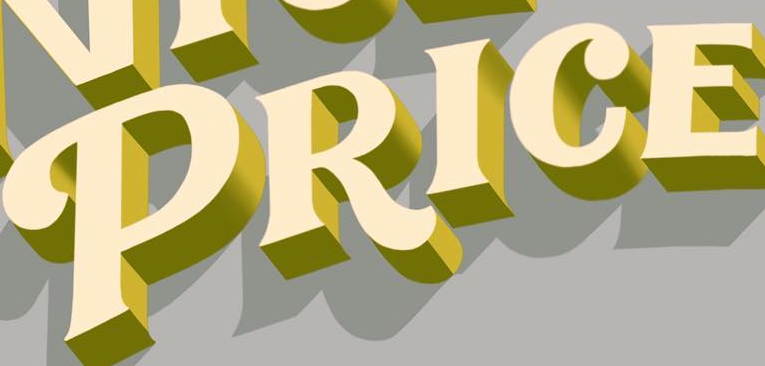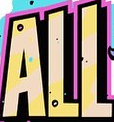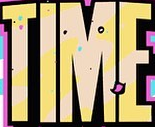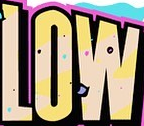Read the text content from these images in order, separated by a semicolon. PRICE; ALL; TIME; LOW 